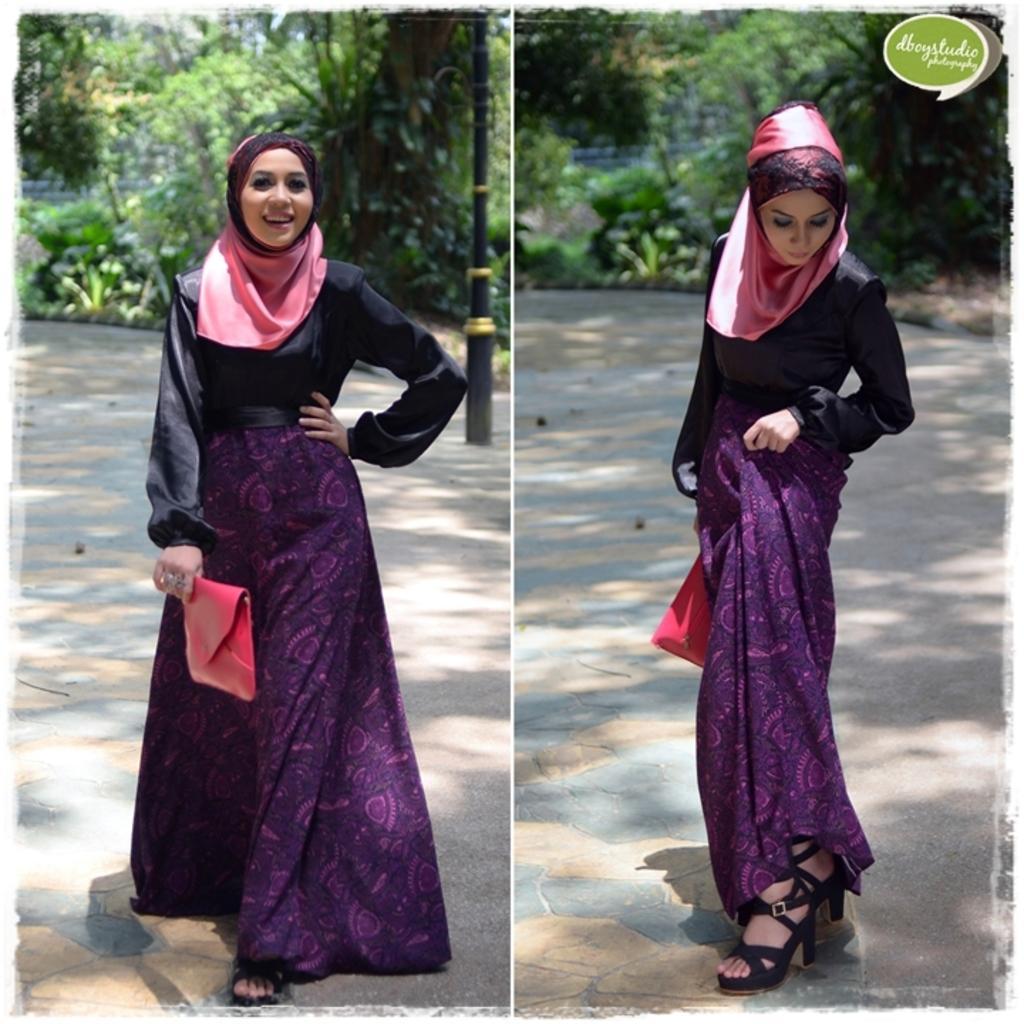In one or two sentences, can you explain what this image depicts? This is a collage image, we can see a woman is standing in different positions and holding a red object. Behind the woman there is a pole and trees. On the image there is a watermark. 